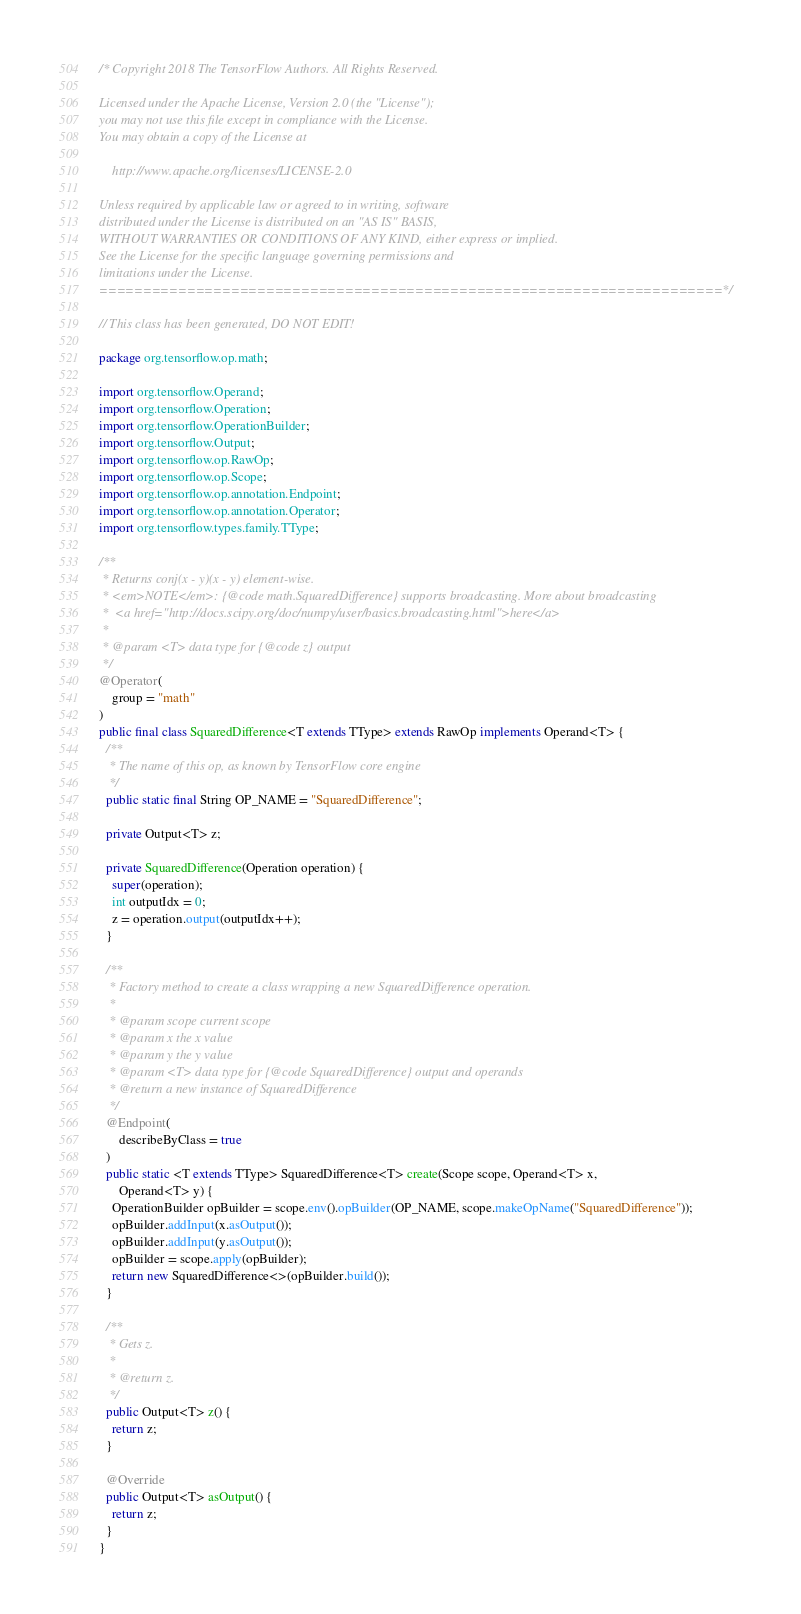<code> <loc_0><loc_0><loc_500><loc_500><_Java_>/* Copyright 2018 The TensorFlow Authors. All Rights Reserved.

Licensed under the Apache License, Version 2.0 (the "License");
you may not use this file except in compliance with the License.
You may obtain a copy of the License at

    http://www.apache.org/licenses/LICENSE-2.0

Unless required by applicable law or agreed to in writing, software
distributed under the License is distributed on an "AS IS" BASIS,
WITHOUT WARRANTIES OR CONDITIONS OF ANY KIND, either express or implied.
See the License for the specific language governing permissions and
limitations under the License.
=======================================================================*/

// This class has been generated, DO NOT EDIT!

package org.tensorflow.op.math;

import org.tensorflow.Operand;
import org.tensorflow.Operation;
import org.tensorflow.OperationBuilder;
import org.tensorflow.Output;
import org.tensorflow.op.RawOp;
import org.tensorflow.op.Scope;
import org.tensorflow.op.annotation.Endpoint;
import org.tensorflow.op.annotation.Operator;
import org.tensorflow.types.family.TType;

/**
 * Returns conj(x - y)(x - y) element-wise.
 * <em>NOTE</em>: {@code math.SquaredDifference} supports broadcasting. More about broadcasting
 *  <a href="http://docs.scipy.org/doc/numpy/user/basics.broadcasting.html">here</a>
 *
 * @param <T> data type for {@code z} output
 */
@Operator(
    group = "math"
)
public final class SquaredDifference<T extends TType> extends RawOp implements Operand<T> {
  /**
   * The name of this op, as known by TensorFlow core engine
   */
  public static final String OP_NAME = "SquaredDifference";

  private Output<T> z;

  private SquaredDifference(Operation operation) {
    super(operation);
    int outputIdx = 0;
    z = operation.output(outputIdx++);
  }

  /**
   * Factory method to create a class wrapping a new SquaredDifference operation.
   *
   * @param scope current scope
   * @param x the x value
   * @param y the y value
   * @param <T> data type for {@code SquaredDifference} output and operands
   * @return a new instance of SquaredDifference
   */
  @Endpoint(
      describeByClass = true
  )
  public static <T extends TType> SquaredDifference<T> create(Scope scope, Operand<T> x,
      Operand<T> y) {
    OperationBuilder opBuilder = scope.env().opBuilder(OP_NAME, scope.makeOpName("SquaredDifference"));
    opBuilder.addInput(x.asOutput());
    opBuilder.addInput(y.asOutput());
    opBuilder = scope.apply(opBuilder);
    return new SquaredDifference<>(opBuilder.build());
  }

  /**
   * Gets z.
   *
   * @return z.
   */
  public Output<T> z() {
    return z;
  }

  @Override
  public Output<T> asOutput() {
    return z;
  }
}
</code> 